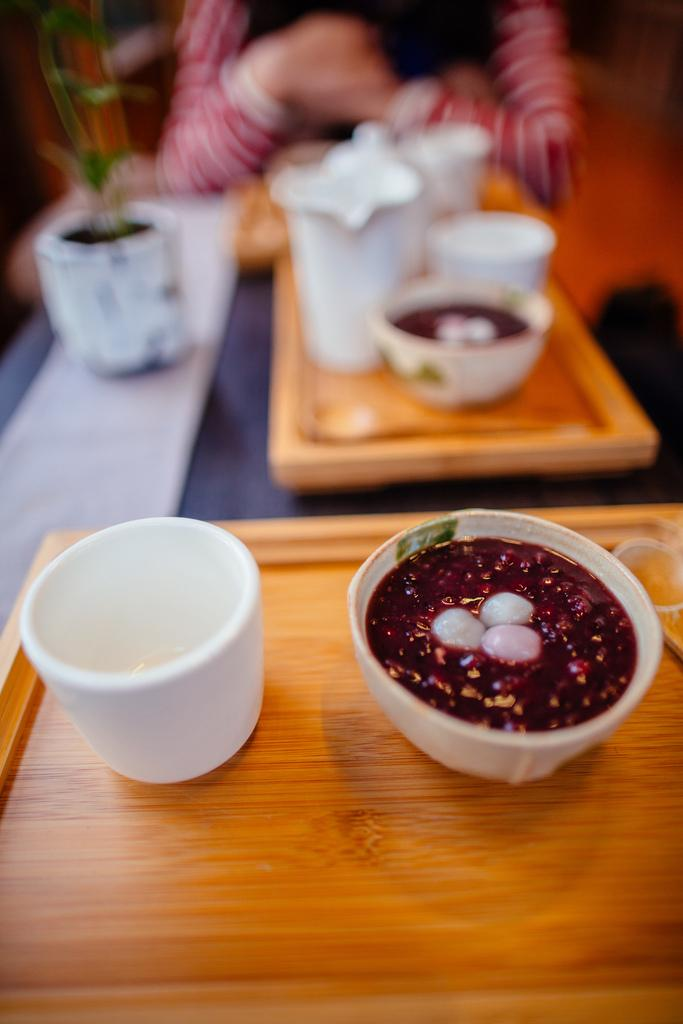What piece of furniture is present in the image? There is a table in the image. What objects are placed on the table? There are two wooden trays on the table. What can be found on the wooden trays? There are bowls on the trays. Who is present in the image? There is a person sitting in front of the table. What type of doll can be heard talking in the image? There is no doll present in the image, and therefore no voice can be heard. 